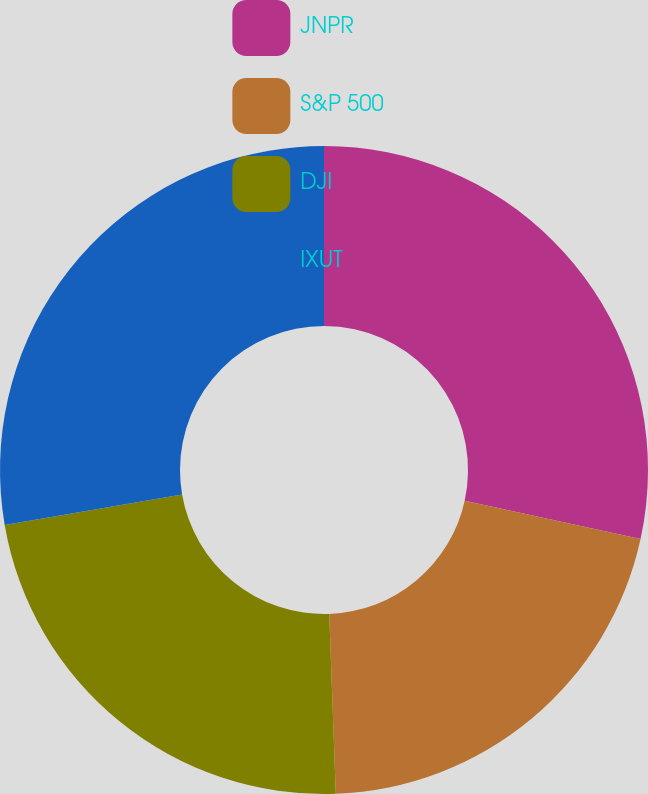Convert chart to OTSL. <chart><loc_0><loc_0><loc_500><loc_500><pie_chart><fcel>JNPR<fcel>S&P 500<fcel>DJI<fcel>IXUT<nl><fcel>28.42%<fcel>21.0%<fcel>22.87%<fcel>27.71%<nl></chart> 